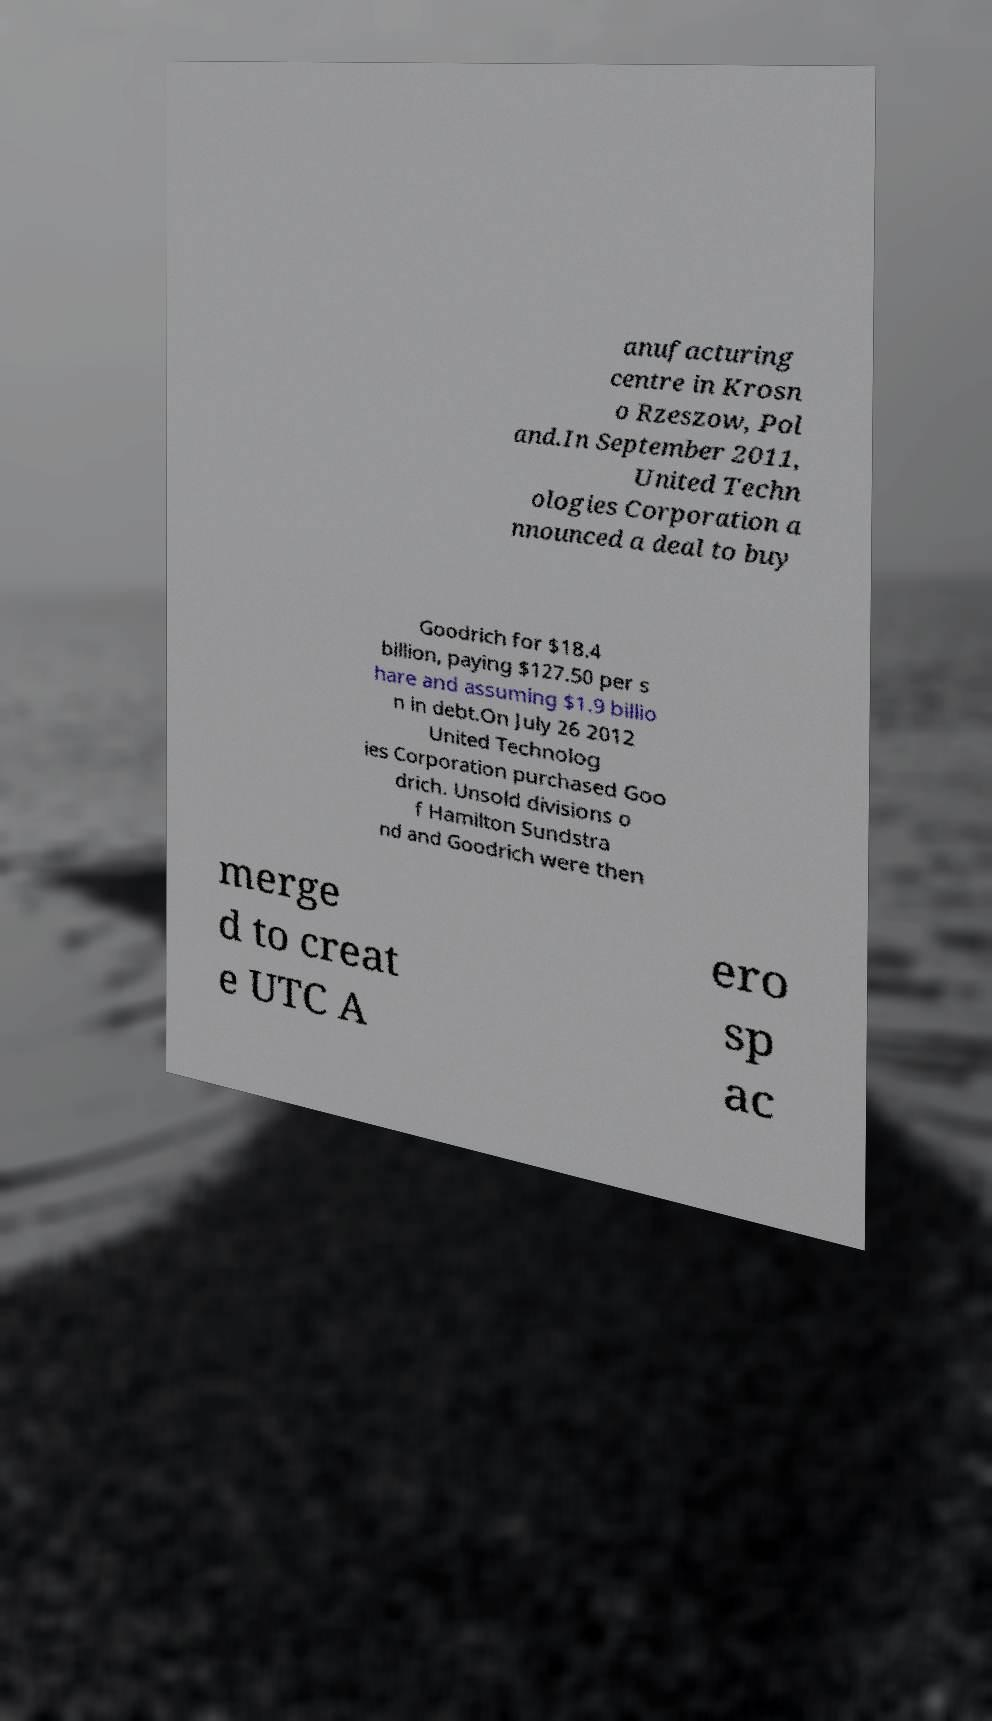Can you read and provide the text displayed in the image?This photo seems to have some interesting text. Can you extract and type it out for me? anufacturing centre in Krosn o Rzeszow, Pol and.In September 2011, United Techn ologies Corporation a nnounced a deal to buy Goodrich for $18.4 billion, paying $127.50 per s hare and assuming $1.9 billio n in debt.On July 26 2012 United Technolog ies Corporation purchased Goo drich. Unsold divisions o f Hamilton Sundstra nd and Goodrich were then merge d to creat e UTC A ero sp ac 